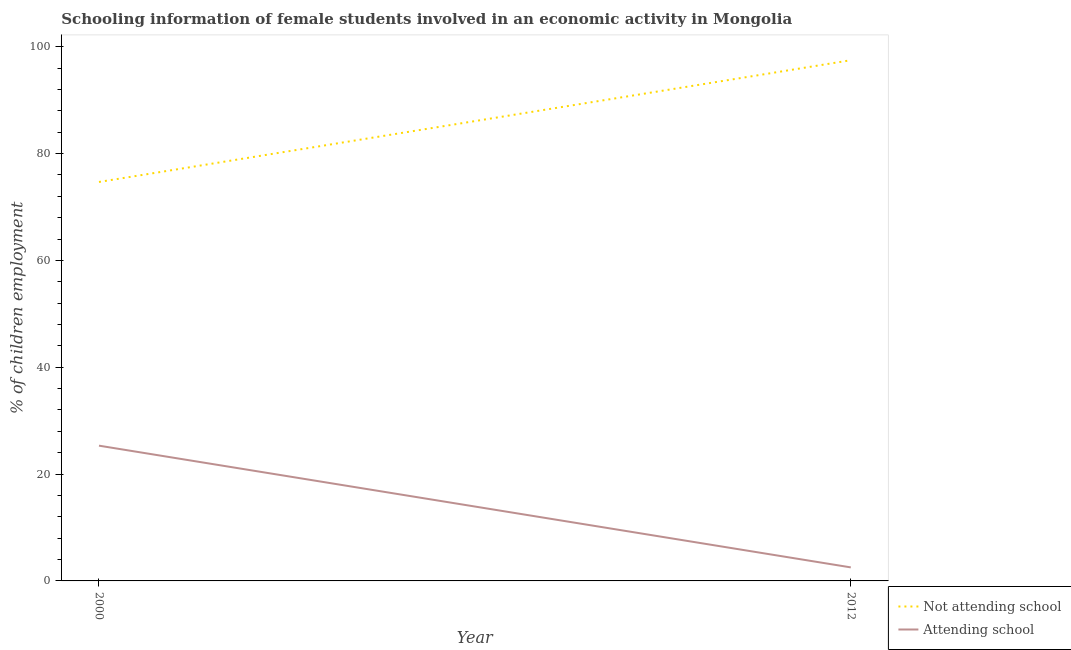Is the number of lines equal to the number of legend labels?
Keep it short and to the point. Yes. What is the percentage of employed females who are not attending school in 2012?
Your answer should be very brief. 97.47. Across all years, what is the maximum percentage of employed females who are not attending school?
Your answer should be very brief. 97.47. Across all years, what is the minimum percentage of employed females who are not attending school?
Keep it short and to the point. 74.68. In which year was the percentage of employed females who are not attending school minimum?
Your answer should be compact. 2000. What is the total percentage of employed females who are not attending school in the graph?
Offer a terse response. 172.15. What is the difference between the percentage of employed females who are attending school in 2000 and that in 2012?
Your answer should be very brief. 22.79. What is the difference between the percentage of employed females who are attending school in 2012 and the percentage of employed females who are not attending school in 2000?
Provide a succinct answer. -72.15. What is the average percentage of employed females who are attending school per year?
Keep it short and to the point. 13.93. In the year 2012, what is the difference between the percentage of employed females who are attending school and percentage of employed females who are not attending school?
Provide a succinct answer. -94.94. In how many years, is the percentage of employed females who are attending school greater than 32 %?
Offer a very short reply. 0. What is the ratio of the percentage of employed females who are not attending school in 2000 to that in 2012?
Give a very brief answer. 0.77. Is the percentage of employed females who are not attending school strictly greater than the percentage of employed females who are attending school over the years?
Offer a terse response. Yes. Is the percentage of employed females who are attending school strictly less than the percentage of employed females who are not attending school over the years?
Your answer should be compact. Yes. How many lines are there?
Keep it short and to the point. 2. How many years are there in the graph?
Offer a terse response. 2. What is the difference between two consecutive major ticks on the Y-axis?
Your answer should be very brief. 20. Does the graph contain any zero values?
Make the answer very short. No. How many legend labels are there?
Provide a succinct answer. 2. How are the legend labels stacked?
Your response must be concise. Vertical. What is the title of the graph?
Your answer should be very brief. Schooling information of female students involved in an economic activity in Mongolia. What is the label or title of the Y-axis?
Ensure brevity in your answer.  % of children employment. What is the % of children employment of Not attending school in 2000?
Give a very brief answer. 74.68. What is the % of children employment in Attending school in 2000?
Ensure brevity in your answer.  25.32. What is the % of children employment in Not attending school in 2012?
Keep it short and to the point. 97.47. What is the % of children employment in Attending school in 2012?
Provide a succinct answer. 2.53. Across all years, what is the maximum % of children employment in Not attending school?
Give a very brief answer. 97.47. Across all years, what is the maximum % of children employment in Attending school?
Your answer should be compact. 25.32. Across all years, what is the minimum % of children employment in Not attending school?
Provide a succinct answer. 74.68. Across all years, what is the minimum % of children employment in Attending school?
Give a very brief answer. 2.53. What is the total % of children employment of Not attending school in the graph?
Provide a short and direct response. 172.15. What is the total % of children employment in Attending school in the graph?
Provide a succinct answer. 27.85. What is the difference between the % of children employment in Not attending school in 2000 and that in 2012?
Provide a succinct answer. -22.79. What is the difference between the % of children employment of Attending school in 2000 and that in 2012?
Make the answer very short. 22.79. What is the difference between the % of children employment in Not attending school in 2000 and the % of children employment in Attending school in 2012?
Your response must be concise. 72.15. What is the average % of children employment in Not attending school per year?
Your answer should be compact. 86.08. What is the average % of children employment of Attending school per year?
Ensure brevity in your answer.  13.93. In the year 2000, what is the difference between the % of children employment in Not attending school and % of children employment in Attending school?
Your answer should be very brief. 49.36. In the year 2012, what is the difference between the % of children employment of Not attending school and % of children employment of Attending school?
Provide a short and direct response. 94.94. What is the ratio of the % of children employment in Not attending school in 2000 to that in 2012?
Offer a terse response. 0.77. What is the ratio of the % of children employment in Attending school in 2000 to that in 2012?
Provide a succinct answer. 10. What is the difference between the highest and the second highest % of children employment of Not attending school?
Your answer should be very brief. 22.79. What is the difference between the highest and the second highest % of children employment in Attending school?
Your answer should be very brief. 22.79. What is the difference between the highest and the lowest % of children employment in Not attending school?
Provide a succinct answer. 22.79. What is the difference between the highest and the lowest % of children employment in Attending school?
Your response must be concise. 22.79. 